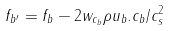<formula> <loc_0><loc_0><loc_500><loc_500>f _ { b ^ { \prime } } = f _ { b } - 2 w _ { c _ { b } } \rho u _ { b } . c _ { b } / c _ { s } ^ { 2 }</formula> 